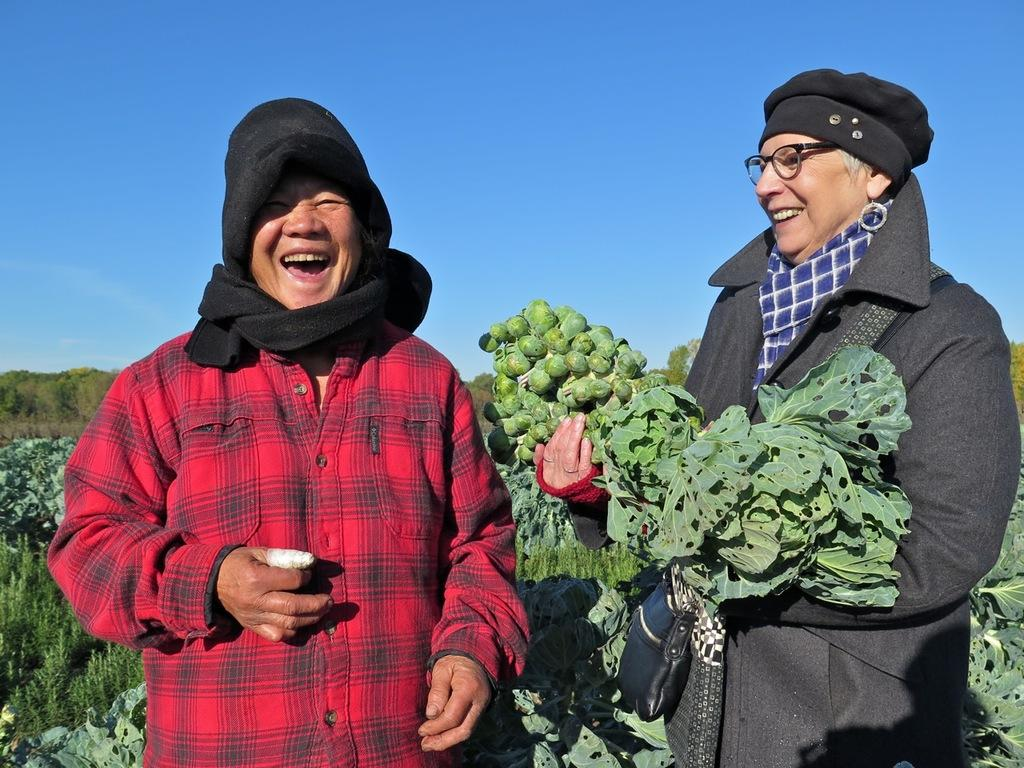How many people are in the image? There are people in the image. Can you describe one of the people in the image? One person is wearing spectacles. What is the person wearing spectacles doing in the image? The person wearing spectacles is holding objects. What type of natural elements can be seen in the image? There are plants and trees in the image. What is visible in the background of the image? The sky is visible in the image. What type of insurance policy is being discussed by the people in the image? There is no indication in the image that the people are discussing insurance policies. --- Facts: 1. There is a car in the image. 2. The car is parked on the street. 3. There are streetlights in the image. 4. The street is visible in the image. 5. There are buildings in the background of the image. Absurd Topics: parrot, sand, volcano Conversation: What is the main subject of the image? The main subject of the image is a car. Where is the car located in the image? The car is parked on the street. What type of lighting is present in the image? There are streetlights in the image. What can be seen on the ground in the image? The street is visible in the image. What is visible in the background of the image? There are buildings in the background of the image. Reasoning: Let's think step by step in order to produce the conversation. We start by identifying the main subject in the image, which is the car. Then, we describe the car's location, which is parked on the street. Next, we mention the presence of streetlights, which provide lighting in the image. We then describe the ground, which is a street. Finally, we describe the background of the image, which includes buildings. Absurd Question/Answer: Can you tell me how many parrots are sitting on the car in the image? There are no parrots present in the image; it features a car parked on the street with streetlights and buildings in the background. 